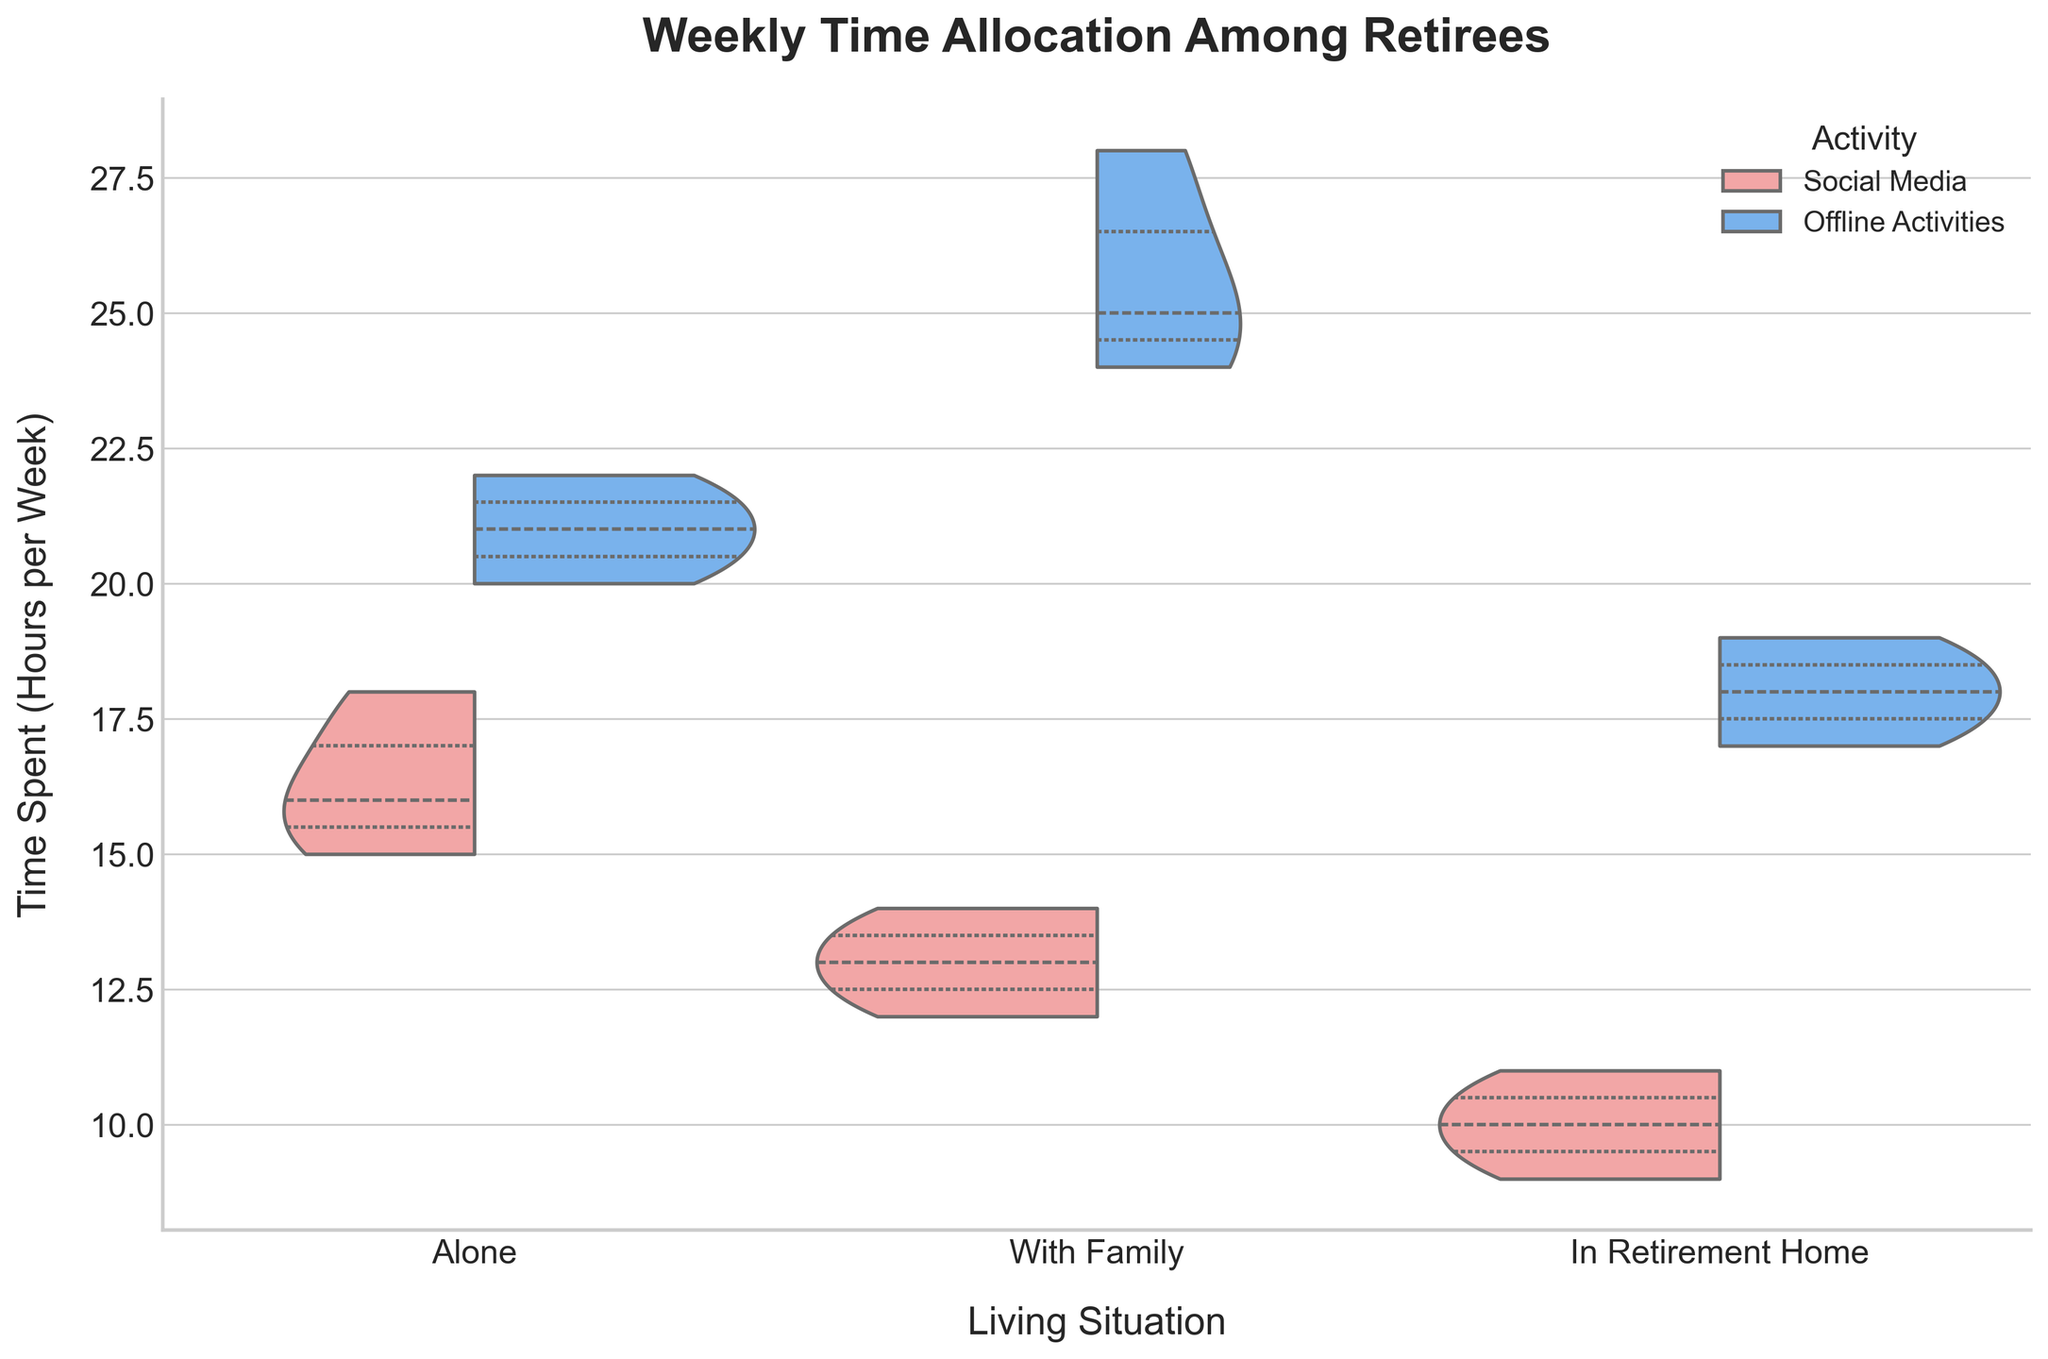What's the title of the figure? The title of the figure is typically displayed at the top center of the plot. In this case, it is stated in the code.
Answer: Weekly Time Allocation Among Retirees What are the different living situations shown in the figure? The x-axis labels correspond to the different living situations. According to the data provided and the axis labels, the living situations are "Alone," "With Family," and "In Retirement Home."
Answer: Alone, With Family, In Retirement Home Which activity shows a wider distribution for retirees living alone, social media or offline activities? The width of the violin parts indicates the distribution of the data points. For those living alone, the distribution for social media is shown by the red violin and for offline activities by the blue violin. By comparing their widths, offline activities appear to show a wider distribution.
Answer: Offline activities What is the median time retirees living with family spend on offline activities? The median is represented by the white dot in the violin plot. For retirees living with family and spending time on offline activities (blue part), the white dot indicates the median value. It falls around 25 hours per week.
Answer: 25 hours per week Which living situation group spends the least median time on social media? The median value for social media use can be seen as the white dot within the red violin parts across different living situations. The smallest median dot is for retirees in a retirement home.
Answer: In Retirement Home How does the median time spent on offline activities for those living alone compare to those living in a retirement home? To compare, observe the white dots within the blue violin parts for both "Alone" and "In Retirement Home." The white dot for "Alone" is at approximately 21 hours per week, while for "In Retirement Home," it is at around 18 hours per week. The retirees living alone spend more median time on offline activities.
Answer: Alone group spends more time What is the difference between the highest and lowest median times spent on social media among all living situations? Identify the highest and lowest medians by looking at the white dots within the red violin parts. The highest is for "Alone" at approximately 16 hours per week, and the lowest is for "In Retirement Home" at around 10 hours per week. Calculating the difference, 16 - 10 = 6 hours per week.
Answer: 6 hours per week Which living situation group shows the closest median times between social media and offline activities? Compare the distances between the white dots in the red and blue parts for each living situation. For "Alone," the medians are at approximately 16 (social media) and 21 (offline activities), a gap of 5 hours. For "With Family," the medians are about 13 (social media) and 25 (offline activities), a gap of 12 hours. For "In Retirement Home," the medians are approximately 10 (social media) and 18 (offline activities), a gap of 8 hours. The "Alone" group has the closest median times.
Answer: Alone group Among retirees living with family, do they spend more time on social media or offline activities? Observe the median times for both parts. The white dot in the red part shows around 13 hours per week for social media, while the white dot in the blue part shows around 25 hours per week for offline activities. Retirees living with family spend more time on offline activities.
Answer: Offline activities For retirees in a retirement home, which activity has a larger interquartile range (IQR)? The interquartile range is depicted by the width of the inner part of the violin plot. For "In Retirement Home," the blue part (offline activities) is wider than the red part (social media). This indicates a larger IQR for offline activities.
Answer: Offline activities 